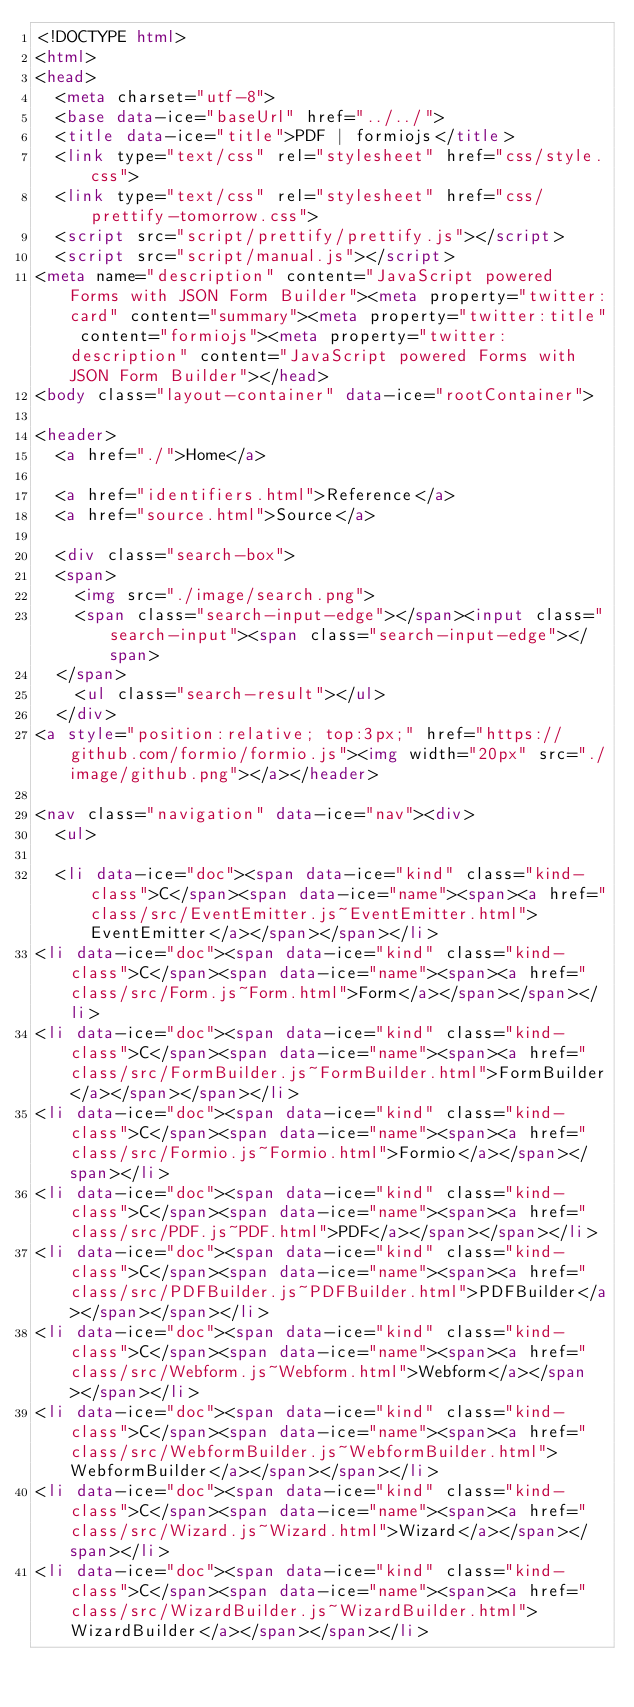<code> <loc_0><loc_0><loc_500><loc_500><_HTML_><!DOCTYPE html>
<html>
<head>
  <meta charset="utf-8">
  <base data-ice="baseUrl" href="../../">
  <title data-ice="title">PDF | formiojs</title>
  <link type="text/css" rel="stylesheet" href="css/style.css">
  <link type="text/css" rel="stylesheet" href="css/prettify-tomorrow.css">
  <script src="script/prettify/prettify.js"></script>
  <script src="script/manual.js"></script>
<meta name="description" content="JavaScript powered Forms with JSON Form Builder"><meta property="twitter:card" content="summary"><meta property="twitter:title" content="formiojs"><meta property="twitter:description" content="JavaScript powered Forms with JSON Form Builder"></head>
<body class="layout-container" data-ice="rootContainer">

<header>
  <a href="./">Home</a>
  
  <a href="identifiers.html">Reference</a>
  <a href="source.html">Source</a>
  
  <div class="search-box">
  <span>
    <img src="./image/search.png">
    <span class="search-input-edge"></span><input class="search-input"><span class="search-input-edge"></span>
  </span>
    <ul class="search-result"></ul>
  </div>
<a style="position:relative; top:3px;" href="https://github.com/formio/formio.js"><img width="20px" src="./image/github.png"></a></header>

<nav class="navigation" data-ice="nav"><div>
  <ul>
    
  <li data-ice="doc"><span data-ice="kind" class="kind-class">C</span><span data-ice="name"><span><a href="class/src/EventEmitter.js~EventEmitter.html">EventEmitter</a></span></span></li>
<li data-ice="doc"><span data-ice="kind" class="kind-class">C</span><span data-ice="name"><span><a href="class/src/Form.js~Form.html">Form</a></span></span></li>
<li data-ice="doc"><span data-ice="kind" class="kind-class">C</span><span data-ice="name"><span><a href="class/src/FormBuilder.js~FormBuilder.html">FormBuilder</a></span></span></li>
<li data-ice="doc"><span data-ice="kind" class="kind-class">C</span><span data-ice="name"><span><a href="class/src/Formio.js~Formio.html">Formio</a></span></span></li>
<li data-ice="doc"><span data-ice="kind" class="kind-class">C</span><span data-ice="name"><span><a href="class/src/PDF.js~PDF.html">PDF</a></span></span></li>
<li data-ice="doc"><span data-ice="kind" class="kind-class">C</span><span data-ice="name"><span><a href="class/src/PDFBuilder.js~PDFBuilder.html">PDFBuilder</a></span></span></li>
<li data-ice="doc"><span data-ice="kind" class="kind-class">C</span><span data-ice="name"><span><a href="class/src/Webform.js~Webform.html">Webform</a></span></span></li>
<li data-ice="doc"><span data-ice="kind" class="kind-class">C</span><span data-ice="name"><span><a href="class/src/WebformBuilder.js~WebformBuilder.html">WebformBuilder</a></span></span></li>
<li data-ice="doc"><span data-ice="kind" class="kind-class">C</span><span data-ice="name"><span><a href="class/src/Wizard.js~Wizard.html">Wizard</a></span></span></li>
<li data-ice="doc"><span data-ice="kind" class="kind-class">C</span><span data-ice="name"><span><a href="class/src/WizardBuilder.js~WizardBuilder.html">WizardBuilder</a></span></span></li></code> 